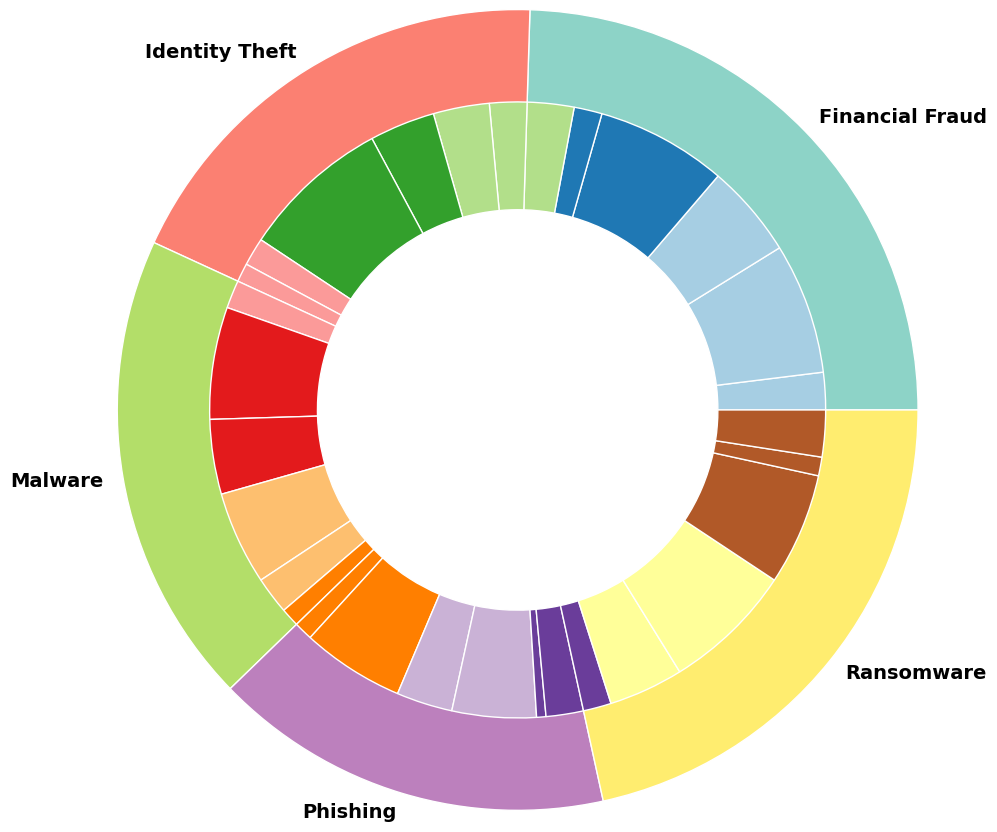What is the most common type of cybercrime based on financial losses? The outer circle in the nested pie chart represents different types of cybercrimes. By comparing the relative sizes, we see that Identity Theft has the largest portion.
Answer: Identity Theft Which region experiences the highest financial loss due to ransomware? The inner slices within the Ransomware section of the pie chart depict losses by region. The North America segment appears largest within the ransomware category.
Answer: North America What is the total financial loss due to phishing in Asia and Europe combined? Looking at the financial losses in the inner pie for phishing, we identify the segments for Asia and Europe and add their values (55000000 for Asia, 30000000 for Europe). Therefore, the total is 55000000 + 30000000.
Answer: 85000000 How does the financial loss due to malware in North America compare to that due to identity theft in Europe? We identify the segments for Malware in North America and Identity theft in Europe. The financial loss due to Malware in North America is 50000000 and that due to Identity Theft in Europe is 35000000. 50000000 is greater than 35000000.
Answer: Malware in North America is higher What is the smallest financial loss for any cybercrime type in Oceania? Inside the inner circles representing Oceania in each crime type, we identify the smallest segment. Phishing shows the smallest financial loss in Oceania with 5000000.
Answer: Phishing How much more is the financial loss due to financial fraud in North America compared to Africa? Locate and compare the inner segments within Financial Fraud for North America and Africa. North America's financial loss is 70000000 and Africa's is 20000000. Subtract them to determine the difference.
Answer: 50000000 Which region has the lowest financial loss across all types of cybercrime? The inner circle segments that correspond to Africa consistently show smaller sizes compared to other regions, indicating overall lower financial losses.
Answer: Africa Between North America and Europe, which region has higher total financial losses due to all cybercrime types? Sum the respective segments across all cybercrime types for both regions. North America's total significantly exceeds that of Europe, leading to a higher financial loss.
Answer: North America What percentage of the total financial losses due to identity theft does Asia contribute? Calculate the total financial loss for Identity Theft, then divide Asia's loss (30000000) by this total and multiply by 100 to convert to percentage.
Answer: 14.29% How does the financial loss due to phishing in South America compare to financial fraud in the same region? Compare segments within South America for Phishing (20000000) and Financial Fraud (25000000). Phishing's financial loss is less than Financial Fraud in South America.
Answer: Financial fraud is higher 